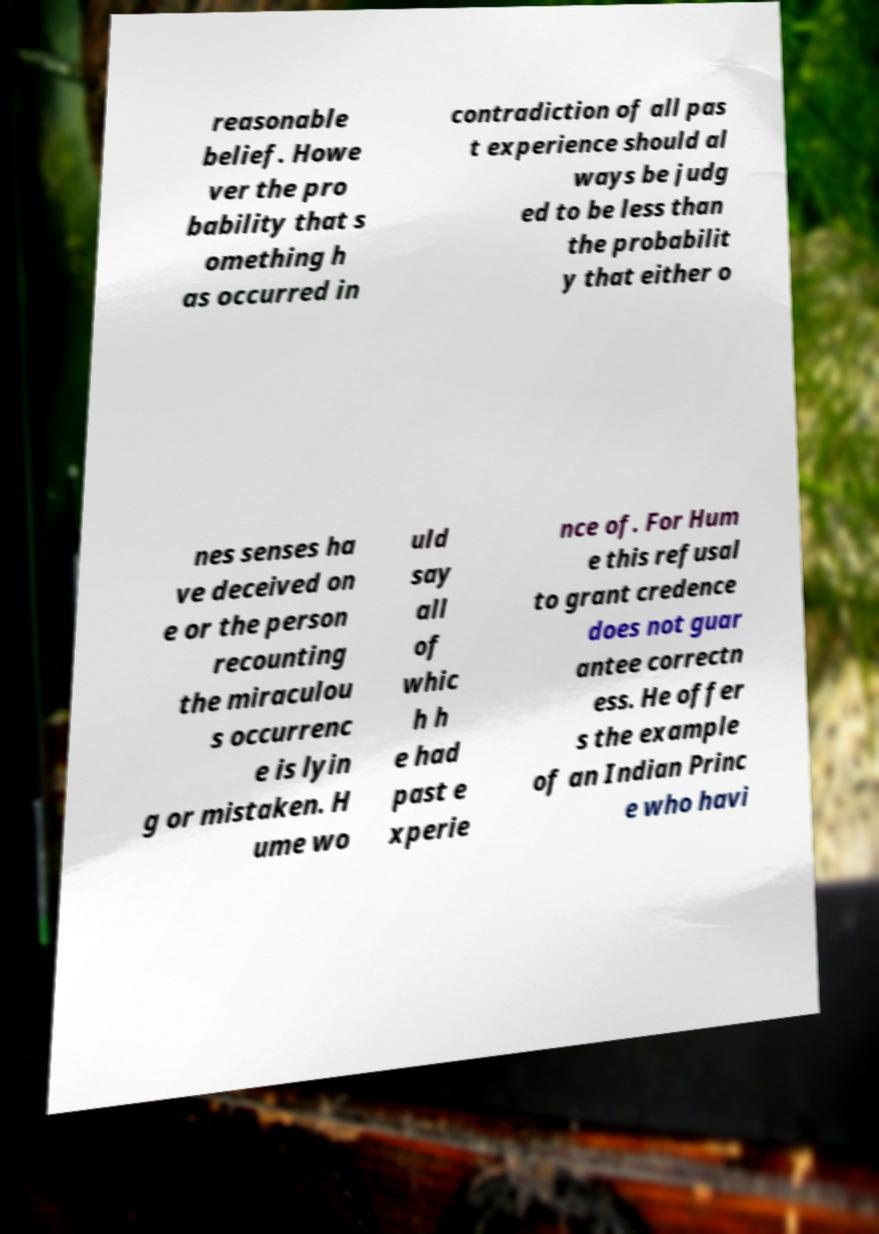I need the written content from this picture converted into text. Can you do that? reasonable belief. Howe ver the pro bability that s omething h as occurred in contradiction of all pas t experience should al ways be judg ed to be less than the probabilit y that either o nes senses ha ve deceived on e or the person recounting the miraculou s occurrenc e is lyin g or mistaken. H ume wo uld say all of whic h h e had past e xperie nce of. For Hum e this refusal to grant credence does not guar antee correctn ess. He offer s the example of an Indian Princ e who havi 